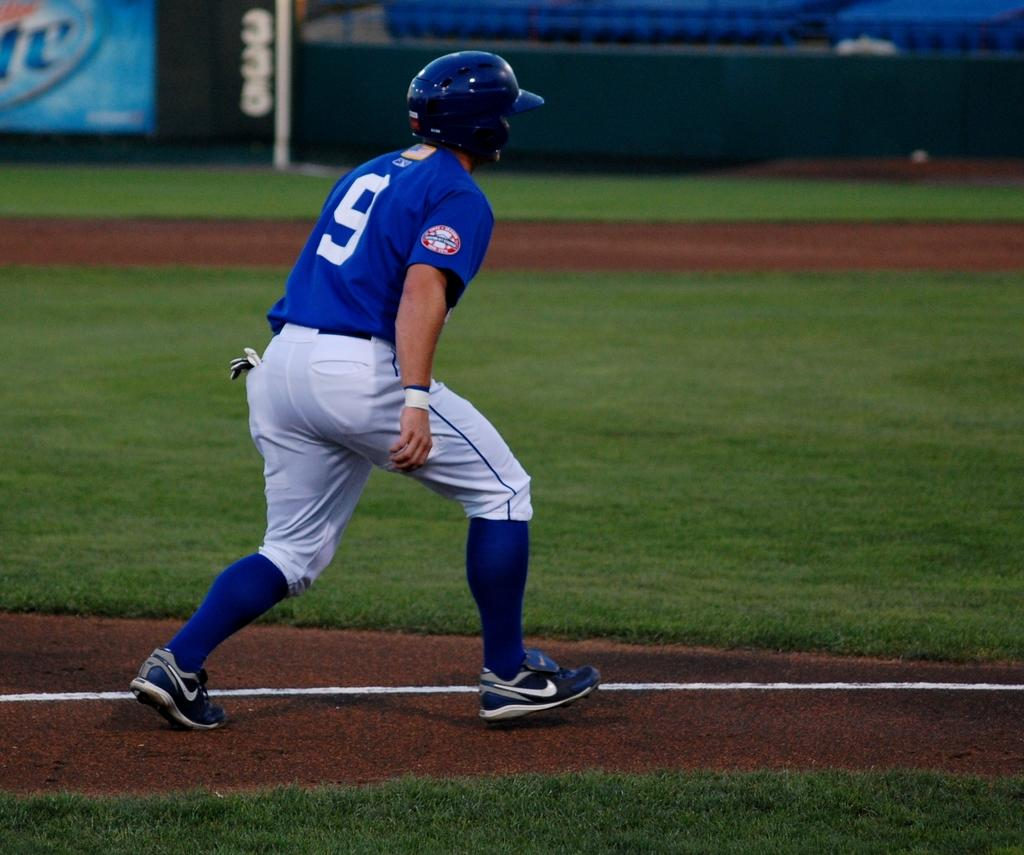What is the main subject of the image? There is a person standing in the center of the image. What is the person standing on? The person is standing on the ground. What type of vegetation can be seen in the background of the image? There is grass visible in the background of the image. What else can be seen in the background of the image? There is a pole in the background of the image. What type of pest can be seen crawling on the person in the image? There are no pests visible in the image; the person is standing alone in the center. Is there a playground present in the image? There is no playground present in the image; it only features a person standing on the ground with grass and a pole in the background. 